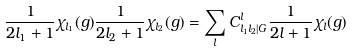Convert formula to latex. <formula><loc_0><loc_0><loc_500><loc_500>\frac { 1 } { 2 l _ { 1 } + 1 } \chi _ { l _ { 1 } } ( g ) \frac { 1 } { 2 l _ { 2 } + 1 } \chi _ { l _ { 2 } } ( g ) = \sum _ { l } C _ { l _ { 1 } l _ { 2 } | G } ^ { l } \frac { 1 } { 2 l + 1 } \chi _ { l } ( g )</formula> 